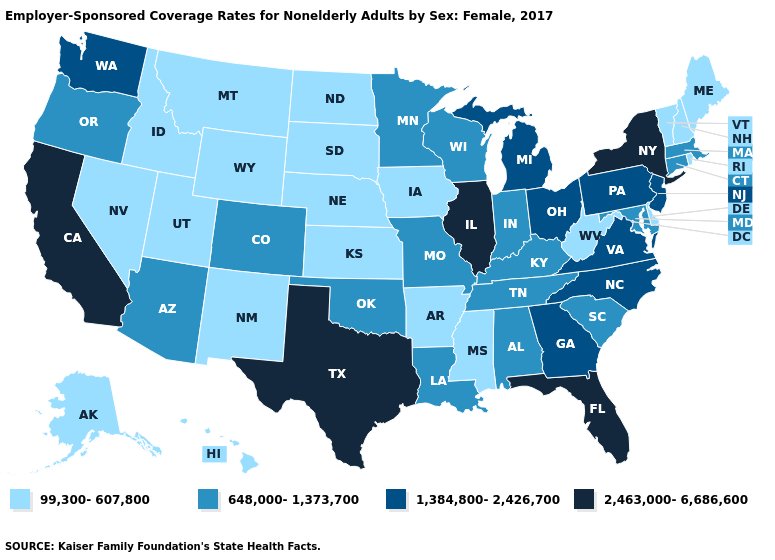Does Texas have the highest value in the South?
Answer briefly. Yes. Name the states that have a value in the range 648,000-1,373,700?
Concise answer only. Alabama, Arizona, Colorado, Connecticut, Indiana, Kentucky, Louisiana, Maryland, Massachusetts, Minnesota, Missouri, Oklahoma, Oregon, South Carolina, Tennessee, Wisconsin. Is the legend a continuous bar?
Keep it brief. No. What is the value of New York?
Be succinct. 2,463,000-6,686,600. Which states have the lowest value in the South?
Short answer required. Arkansas, Delaware, Mississippi, West Virginia. What is the value of Hawaii?
Concise answer only. 99,300-607,800. Name the states that have a value in the range 99,300-607,800?
Keep it brief. Alaska, Arkansas, Delaware, Hawaii, Idaho, Iowa, Kansas, Maine, Mississippi, Montana, Nebraska, Nevada, New Hampshire, New Mexico, North Dakota, Rhode Island, South Dakota, Utah, Vermont, West Virginia, Wyoming. Name the states that have a value in the range 2,463,000-6,686,600?
Concise answer only. California, Florida, Illinois, New York, Texas. What is the value of Iowa?
Be succinct. 99,300-607,800. Does Missouri have the highest value in the MidWest?
Be succinct. No. Is the legend a continuous bar?
Answer briefly. No. Does the map have missing data?
Concise answer only. No. Name the states that have a value in the range 99,300-607,800?
Be succinct. Alaska, Arkansas, Delaware, Hawaii, Idaho, Iowa, Kansas, Maine, Mississippi, Montana, Nebraska, Nevada, New Hampshire, New Mexico, North Dakota, Rhode Island, South Dakota, Utah, Vermont, West Virginia, Wyoming. What is the value of Washington?
Write a very short answer. 1,384,800-2,426,700. Does New York have the highest value in the Northeast?
Concise answer only. Yes. 